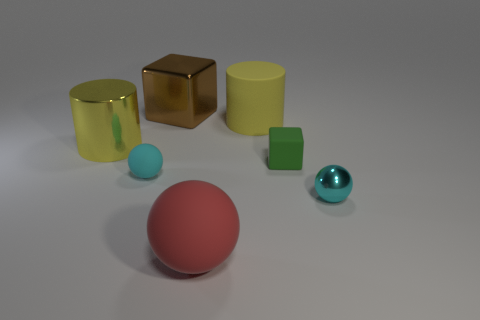The metal cylinder that is the same size as the yellow matte thing is what color?
Your answer should be compact. Yellow. What is the color of the sphere that is both behind the big rubber sphere and to the left of the small metallic sphere?
Your answer should be very brief. Cyan. What is the size of the object that is the same color as the large metallic cylinder?
Keep it short and to the point. Large. What shape is the object that is the same color as the tiny metal ball?
Make the answer very short. Sphere. There is a block that is in front of the yellow thing that is right of the yellow thing left of the large block; what size is it?
Your response must be concise. Small. What material is the red thing?
Your answer should be very brief. Rubber. Are the green object and the object to the right of the green block made of the same material?
Keep it short and to the point. No. Are there any other things that are the same color as the small shiny sphere?
Your answer should be very brief. Yes. Are there any cyan shiny objects that are on the left side of the cyan sphere in front of the small object to the left of the brown metal block?
Give a very brief answer. No. The big shiny cylinder is what color?
Provide a succinct answer. Yellow. 